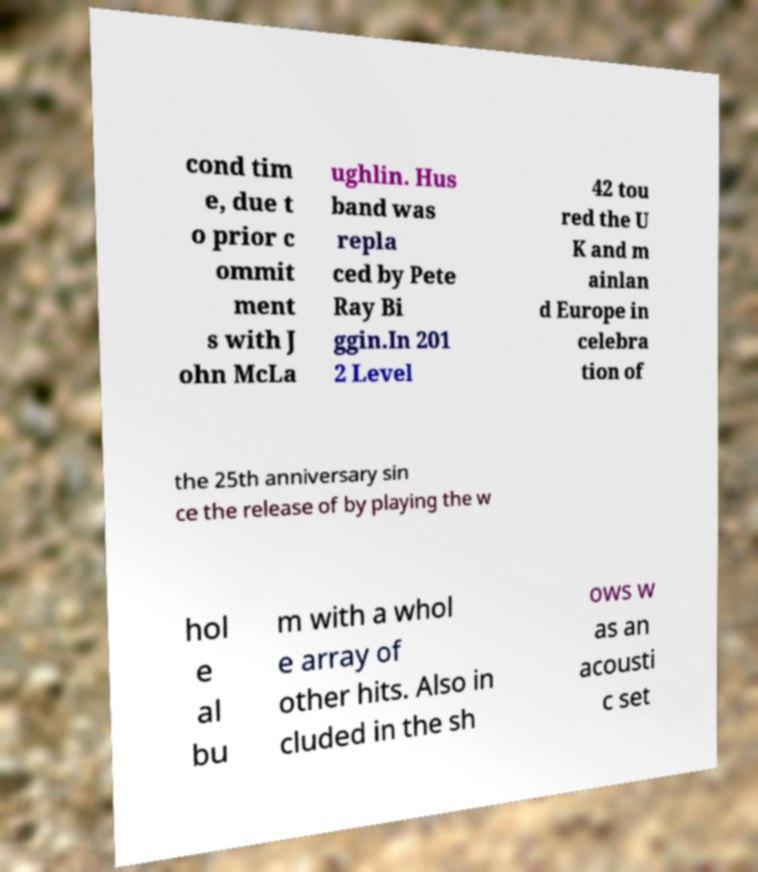There's text embedded in this image that I need extracted. Can you transcribe it verbatim? cond tim e, due t o prior c ommit ment s with J ohn McLa ughlin. Hus band was repla ced by Pete Ray Bi ggin.In 201 2 Level 42 tou red the U K and m ainlan d Europe in celebra tion of the 25th anniversary sin ce the release of by playing the w hol e al bu m with a whol e array of other hits. Also in cluded in the sh ows w as an acousti c set 